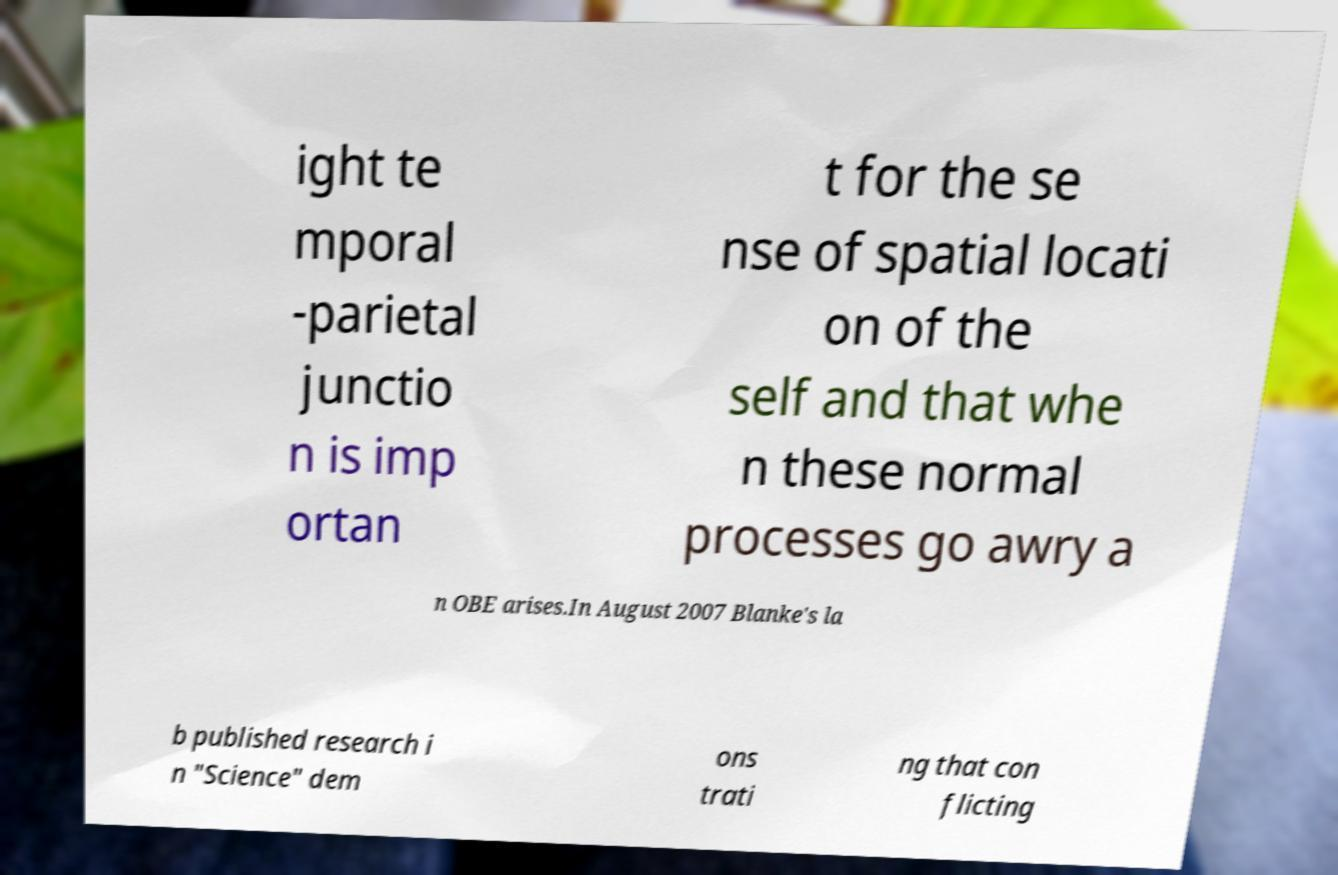Please read and relay the text visible in this image. What does it say? ight te mporal -parietal junctio n is imp ortan t for the se nse of spatial locati on of the self and that whe n these normal processes go awry a n OBE arises.In August 2007 Blanke's la b published research i n "Science" dem ons trati ng that con flicting 